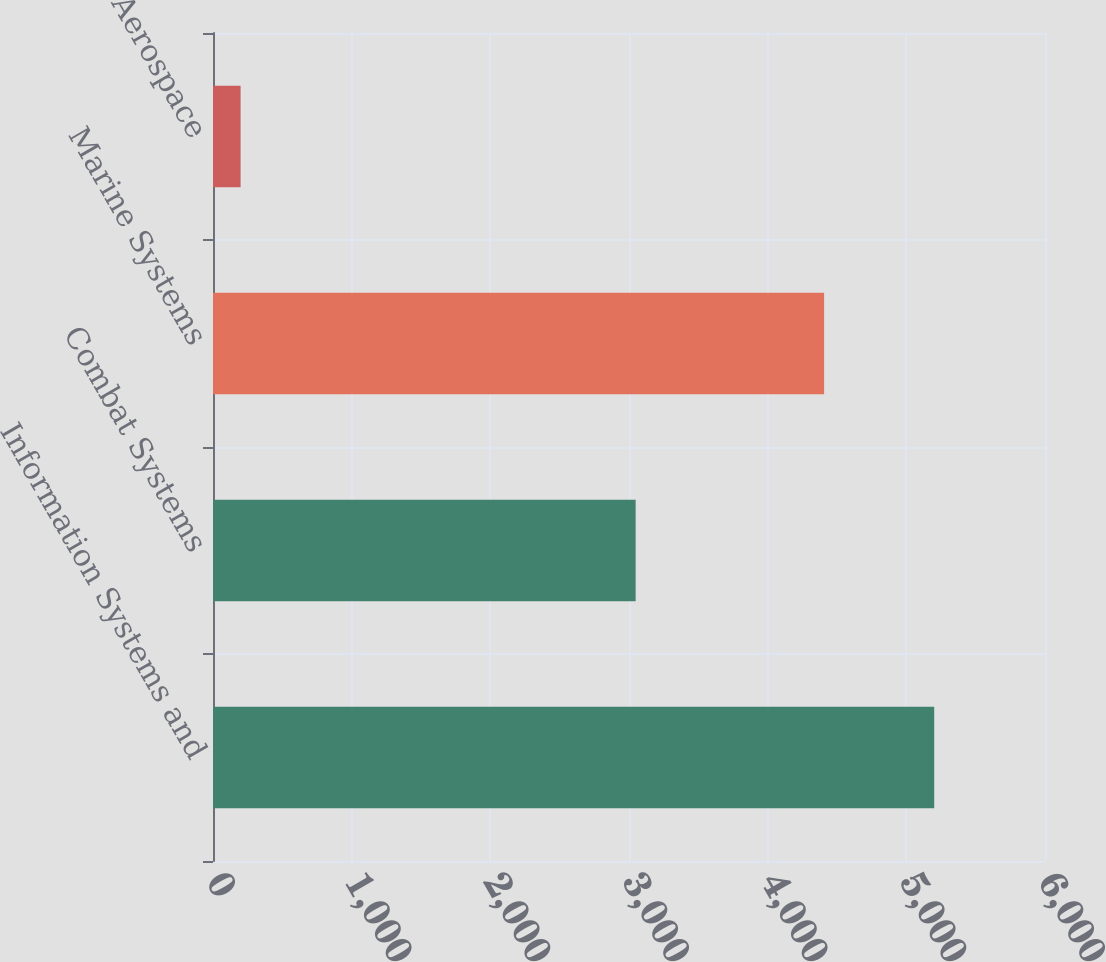<chart> <loc_0><loc_0><loc_500><loc_500><bar_chart><fcel>Information Systems and<fcel>Combat Systems<fcel>Marine Systems<fcel>Aerospace<nl><fcel>5201<fcel>3048<fcel>4407<fcel>199<nl></chart> 